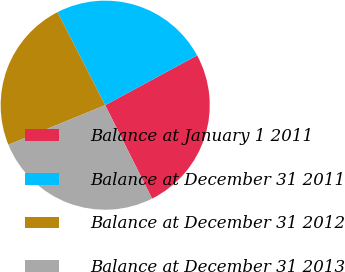Convert chart to OTSL. <chart><loc_0><loc_0><loc_500><loc_500><pie_chart><fcel>Balance at January 1 2011<fcel>Balance at December 31 2011<fcel>Balance at December 31 2012<fcel>Balance at December 31 2013<nl><fcel>25.5%<fcel>24.63%<fcel>23.65%<fcel>26.22%<nl></chart> 